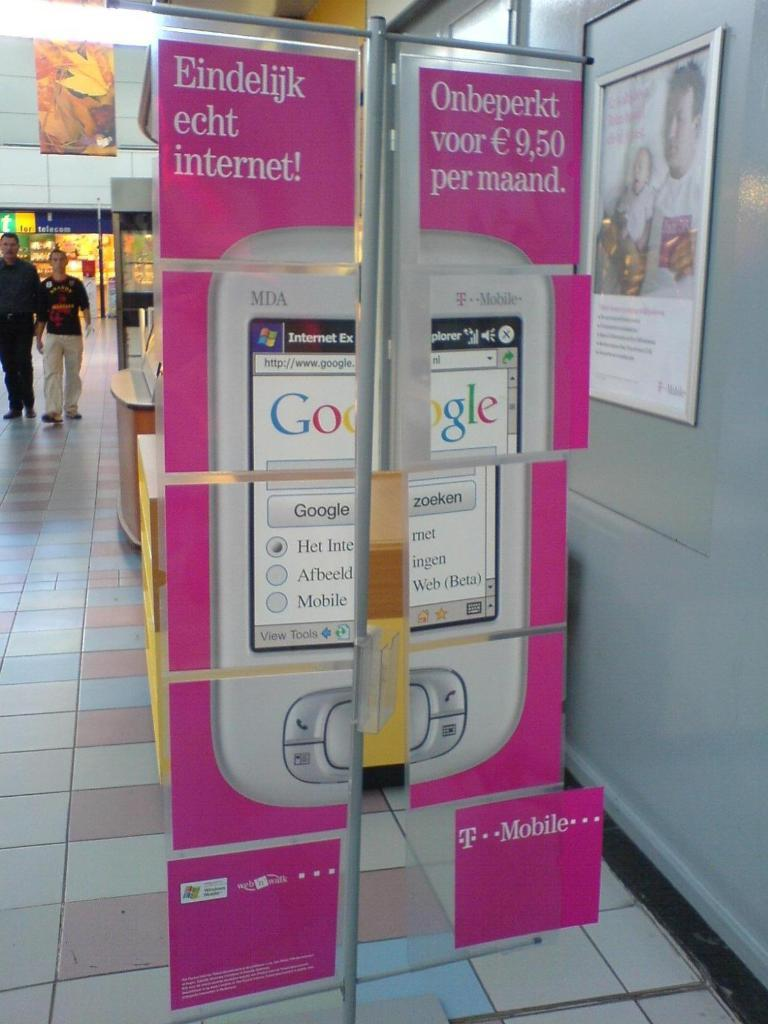Provide a one-sentence caption for the provided image. Cardboard display of a cell phone with Google on it in a shopping center. 